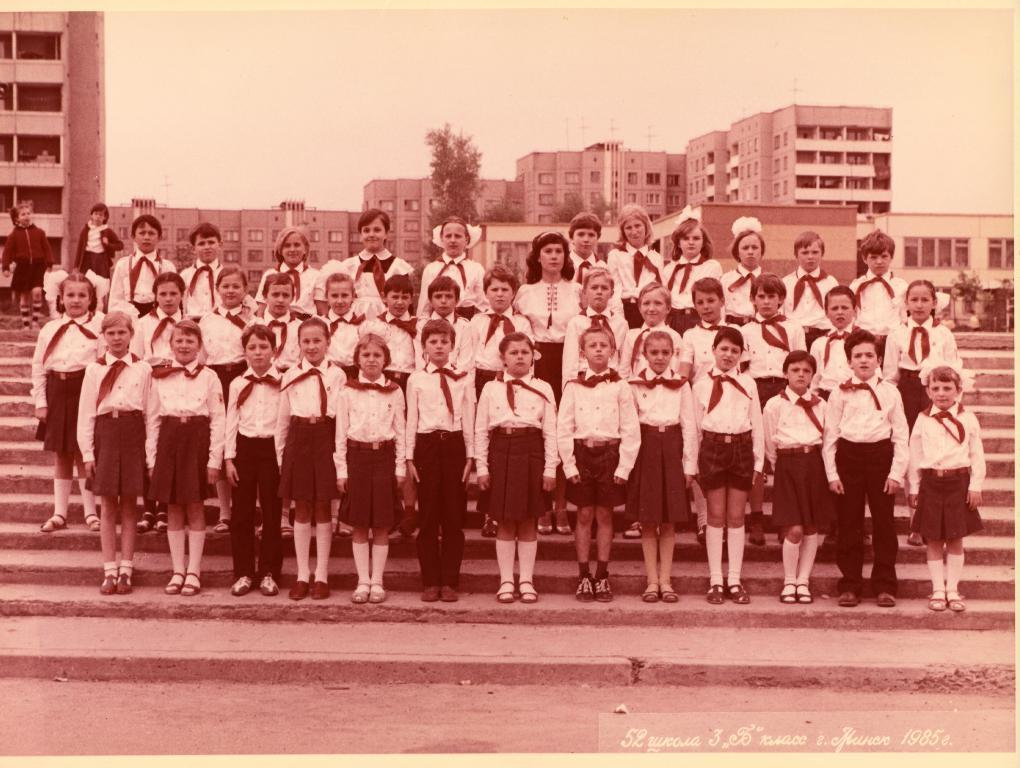What can be seen in the image? There are people standing in the image. What architectural feature is present in the image? There are steps in the image. What can be seen in the background of the image? There are trees, buildings, and the sky visible in the background of the image. Reasoning: Let' Let's think step by step in order to produce the conversation. We start by identifying the main subjects in the image, which are the people standing. Then, we describe the architectural feature present, which are the steps. Finally, we expand the conversation to include the background elements, such as trees, buildings, and the sky. Each question is designed to elicit a specific detail about the image that is known from the provided facts. Absurd Question/Answer: What type of ink is being used by the queen in the image? There is no queen present in the image, and therefore no ink usage can be observed. How many deer are visible in the image? There are no deer present in the image. What type of ink is being used by the queen in the image? There is no queen present in the image, and therefore no ink usage can be observed. How many deer are visible in the image? There are no deer present in the image. 